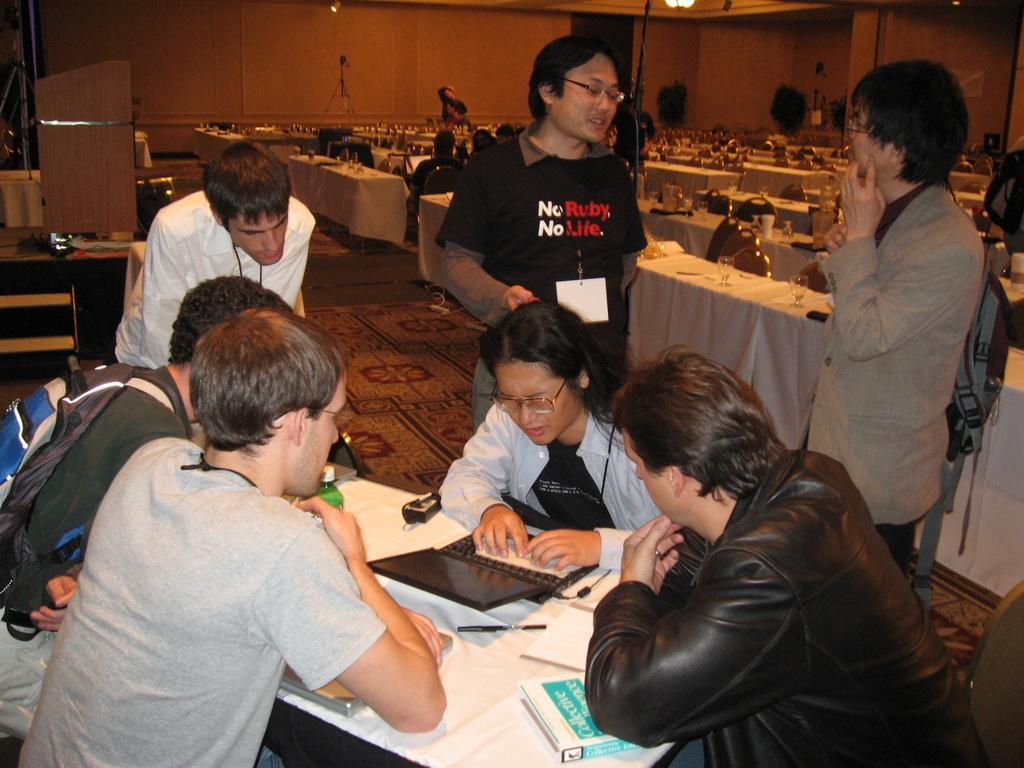Can you describe this image briefly? There is a group of persons present at the bottom of this image. We can see books, laptop and other objects are present on a table. There are tables, chairs, glasses and other objects are present in the background. There is a wall at the top of this image. 